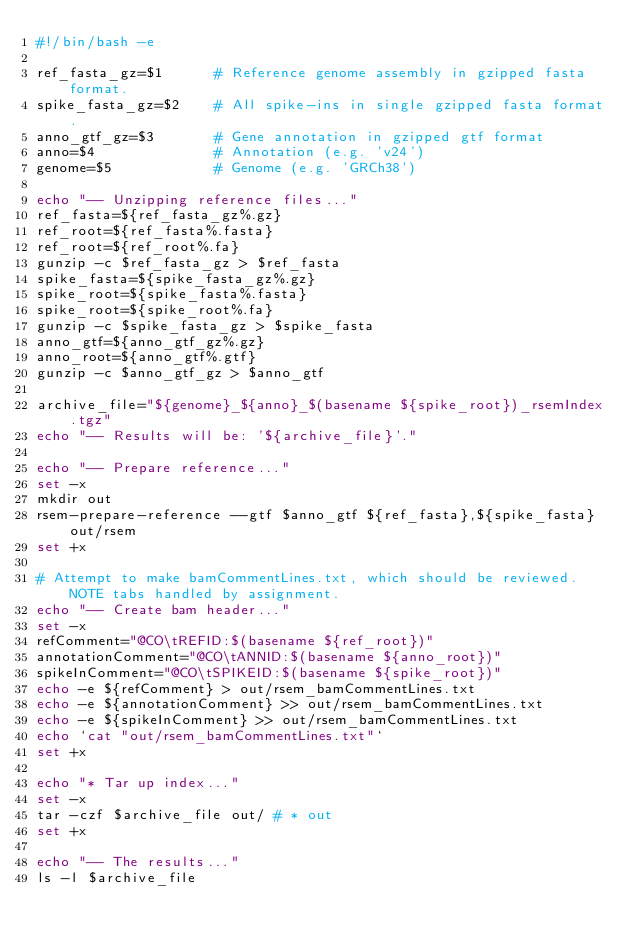<code> <loc_0><loc_0><loc_500><loc_500><_Bash_>#!/bin/bash -e

ref_fasta_gz=$1      # Reference genome assembly in gzipped fasta format.
spike_fasta_gz=$2    # All spike-ins in single gzipped fasta format.
anno_gtf_gz=$3       # Gene annotation in gzipped gtf format
anno=$4              # Annotation (e.g. 'v24')
genome=$5            # Genome (e.g. 'GRCh38')

echo "-- Unzipping reference files..."
ref_fasta=${ref_fasta_gz%.gz}
ref_root=${ref_fasta%.fasta}
ref_root=${ref_root%.fa}
gunzip -c $ref_fasta_gz > $ref_fasta
spike_fasta=${spike_fasta_gz%.gz}
spike_root=${spike_fasta%.fasta}
spike_root=${spike_root%.fa}
gunzip -c $spike_fasta_gz > $spike_fasta
anno_gtf=${anno_gtf_gz%.gz}
anno_root=${anno_gtf%.gtf}
gunzip -c $anno_gtf_gz > $anno_gtf

archive_file="${genome}_${anno}_$(basename ${spike_root})_rsemIndex.tgz"
echo "-- Results will be: '${archive_file}'."

echo "-- Prepare reference..."
set -x
mkdir out
rsem-prepare-reference --gtf $anno_gtf ${ref_fasta},${spike_fasta} out/rsem
set +x

# Attempt to make bamCommentLines.txt, which should be reviewed. NOTE tabs handled by assignment.
echo "-- Create bam header..."
set -x
refComment="@CO\tREFID:$(basename ${ref_root})"
annotationComment="@CO\tANNID:$(basename ${anno_root})"
spikeInComment="@CO\tSPIKEID:$(basename ${spike_root})"
echo -e ${refComment} > out/rsem_bamCommentLines.txt
echo -e ${annotationComment} >> out/rsem_bamCommentLines.txt
echo -e ${spikeInComment} >> out/rsem_bamCommentLines.txt
echo `cat "out/rsem_bamCommentLines.txt"`
set +x

echo "* Tar up index..."
set -x
tar -czf $archive_file out/ # * out
set +x

echo "-- The results..."
ls -l $archive_file
</code> 